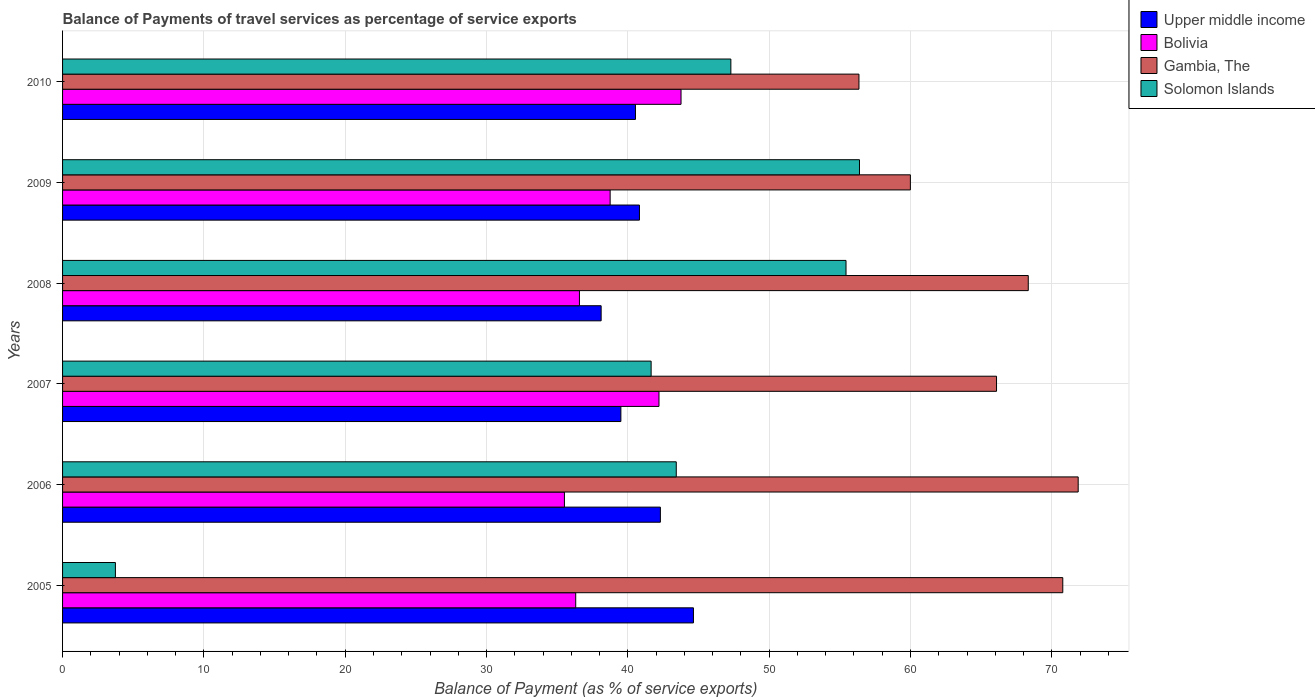How many different coloured bars are there?
Provide a succinct answer. 4. How many groups of bars are there?
Offer a terse response. 6. In how many cases, is the number of bars for a given year not equal to the number of legend labels?
Offer a very short reply. 0. What is the balance of payments of travel services in Gambia, The in 2006?
Give a very brief answer. 71.86. Across all years, what is the maximum balance of payments of travel services in Bolivia?
Make the answer very short. 43.76. Across all years, what is the minimum balance of payments of travel services in Bolivia?
Make the answer very short. 35.51. In which year was the balance of payments of travel services in Solomon Islands minimum?
Make the answer very short. 2005. What is the total balance of payments of travel services in Solomon Islands in the graph?
Make the answer very short. 247.92. What is the difference between the balance of payments of travel services in Upper middle income in 2007 and that in 2010?
Offer a terse response. -1.03. What is the difference between the balance of payments of travel services in Bolivia in 2009 and the balance of payments of travel services in Gambia, The in 2007?
Your answer should be very brief. -27.34. What is the average balance of payments of travel services in Solomon Islands per year?
Your answer should be compact. 41.32. In the year 2009, what is the difference between the balance of payments of travel services in Gambia, The and balance of payments of travel services in Upper middle income?
Your answer should be very brief. 19.17. What is the ratio of the balance of payments of travel services in Bolivia in 2005 to that in 2010?
Provide a short and direct response. 0.83. Is the balance of payments of travel services in Gambia, The in 2009 less than that in 2010?
Give a very brief answer. No. Is the difference between the balance of payments of travel services in Gambia, The in 2006 and 2010 greater than the difference between the balance of payments of travel services in Upper middle income in 2006 and 2010?
Your answer should be very brief. Yes. What is the difference between the highest and the second highest balance of payments of travel services in Gambia, The?
Ensure brevity in your answer.  1.09. What is the difference between the highest and the lowest balance of payments of travel services in Upper middle income?
Give a very brief answer. 6.53. Is the sum of the balance of payments of travel services in Solomon Islands in 2008 and 2010 greater than the maximum balance of payments of travel services in Upper middle income across all years?
Provide a succinct answer. Yes. What does the 3rd bar from the top in 2010 represents?
Offer a very short reply. Bolivia. What does the 1st bar from the bottom in 2008 represents?
Offer a terse response. Upper middle income. What is the difference between two consecutive major ticks on the X-axis?
Keep it short and to the point. 10. Does the graph contain grids?
Your answer should be compact. Yes. How many legend labels are there?
Keep it short and to the point. 4. How are the legend labels stacked?
Offer a terse response. Vertical. What is the title of the graph?
Offer a very short reply. Balance of Payments of travel services as percentage of service exports. Does "Senegal" appear as one of the legend labels in the graph?
Give a very brief answer. No. What is the label or title of the X-axis?
Your answer should be very brief. Balance of Payment (as % of service exports). What is the Balance of Payment (as % of service exports) of Upper middle income in 2005?
Ensure brevity in your answer.  44.64. What is the Balance of Payment (as % of service exports) in Bolivia in 2005?
Give a very brief answer. 36.31. What is the Balance of Payment (as % of service exports) of Gambia, The in 2005?
Offer a terse response. 70.77. What is the Balance of Payment (as % of service exports) in Solomon Islands in 2005?
Your response must be concise. 3.74. What is the Balance of Payment (as % of service exports) in Upper middle income in 2006?
Your answer should be very brief. 42.3. What is the Balance of Payment (as % of service exports) in Bolivia in 2006?
Your answer should be compact. 35.51. What is the Balance of Payment (as % of service exports) of Gambia, The in 2006?
Offer a terse response. 71.86. What is the Balance of Payment (as % of service exports) in Solomon Islands in 2006?
Keep it short and to the point. 43.42. What is the Balance of Payment (as % of service exports) of Upper middle income in 2007?
Your response must be concise. 39.51. What is the Balance of Payment (as % of service exports) in Bolivia in 2007?
Keep it short and to the point. 42.2. What is the Balance of Payment (as % of service exports) of Gambia, The in 2007?
Offer a very short reply. 66.09. What is the Balance of Payment (as % of service exports) in Solomon Islands in 2007?
Your answer should be compact. 41.65. What is the Balance of Payment (as % of service exports) of Upper middle income in 2008?
Make the answer very short. 38.11. What is the Balance of Payment (as % of service exports) of Bolivia in 2008?
Give a very brief answer. 36.57. What is the Balance of Payment (as % of service exports) in Gambia, The in 2008?
Your answer should be very brief. 68.33. What is the Balance of Payment (as % of service exports) of Solomon Islands in 2008?
Provide a short and direct response. 55.44. What is the Balance of Payment (as % of service exports) in Upper middle income in 2009?
Provide a succinct answer. 40.82. What is the Balance of Payment (as % of service exports) in Bolivia in 2009?
Keep it short and to the point. 38.75. What is the Balance of Payment (as % of service exports) in Gambia, The in 2009?
Make the answer very short. 59.99. What is the Balance of Payment (as % of service exports) of Solomon Islands in 2009?
Keep it short and to the point. 56.39. What is the Balance of Payment (as % of service exports) in Upper middle income in 2010?
Your response must be concise. 40.54. What is the Balance of Payment (as % of service exports) in Bolivia in 2010?
Your answer should be very brief. 43.76. What is the Balance of Payment (as % of service exports) of Gambia, The in 2010?
Give a very brief answer. 56.35. What is the Balance of Payment (as % of service exports) in Solomon Islands in 2010?
Ensure brevity in your answer.  47.29. Across all years, what is the maximum Balance of Payment (as % of service exports) in Upper middle income?
Provide a succinct answer. 44.64. Across all years, what is the maximum Balance of Payment (as % of service exports) in Bolivia?
Your response must be concise. 43.76. Across all years, what is the maximum Balance of Payment (as % of service exports) of Gambia, The?
Your answer should be compact. 71.86. Across all years, what is the maximum Balance of Payment (as % of service exports) of Solomon Islands?
Give a very brief answer. 56.39. Across all years, what is the minimum Balance of Payment (as % of service exports) in Upper middle income?
Your answer should be very brief. 38.11. Across all years, what is the minimum Balance of Payment (as % of service exports) in Bolivia?
Keep it short and to the point. 35.51. Across all years, what is the minimum Balance of Payment (as % of service exports) in Gambia, The?
Your answer should be very brief. 56.35. Across all years, what is the minimum Balance of Payment (as % of service exports) in Solomon Islands?
Keep it short and to the point. 3.74. What is the total Balance of Payment (as % of service exports) of Upper middle income in the graph?
Provide a short and direct response. 245.91. What is the total Balance of Payment (as % of service exports) in Bolivia in the graph?
Provide a short and direct response. 233.1. What is the total Balance of Payment (as % of service exports) in Gambia, The in the graph?
Keep it short and to the point. 393.4. What is the total Balance of Payment (as % of service exports) of Solomon Islands in the graph?
Your response must be concise. 247.92. What is the difference between the Balance of Payment (as % of service exports) in Upper middle income in 2005 and that in 2006?
Provide a succinct answer. 2.34. What is the difference between the Balance of Payment (as % of service exports) of Bolivia in 2005 and that in 2006?
Provide a short and direct response. 0.8. What is the difference between the Balance of Payment (as % of service exports) in Gambia, The in 2005 and that in 2006?
Keep it short and to the point. -1.09. What is the difference between the Balance of Payment (as % of service exports) of Solomon Islands in 2005 and that in 2006?
Offer a very short reply. -39.69. What is the difference between the Balance of Payment (as % of service exports) in Upper middle income in 2005 and that in 2007?
Keep it short and to the point. 5.13. What is the difference between the Balance of Payment (as % of service exports) in Bolivia in 2005 and that in 2007?
Your answer should be compact. -5.89. What is the difference between the Balance of Payment (as % of service exports) in Gambia, The in 2005 and that in 2007?
Provide a short and direct response. 4.69. What is the difference between the Balance of Payment (as % of service exports) in Solomon Islands in 2005 and that in 2007?
Your response must be concise. -37.91. What is the difference between the Balance of Payment (as % of service exports) in Upper middle income in 2005 and that in 2008?
Your response must be concise. 6.53. What is the difference between the Balance of Payment (as % of service exports) of Bolivia in 2005 and that in 2008?
Offer a very short reply. -0.26. What is the difference between the Balance of Payment (as % of service exports) in Gambia, The in 2005 and that in 2008?
Offer a terse response. 2.44. What is the difference between the Balance of Payment (as % of service exports) in Solomon Islands in 2005 and that in 2008?
Your response must be concise. -51.7. What is the difference between the Balance of Payment (as % of service exports) in Upper middle income in 2005 and that in 2009?
Your answer should be very brief. 3.82. What is the difference between the Balance of Payment (as % of service exports) of Bolivia in 2005 and that in 2009?
Your answer should be compact. -2.44. What is the difference between the Balance of Payment (as % of service exports) of Gambia, The in 2005 and that in 2009?
Give a very brief answer. 10.78. What is the difference between the Balance of Payment (as % of service exports) of Solomon Islands in 2005 and that in 2009?
Offer a very short reply. -52.65. What is the difference between the Balance of Payment (as % of service exports) in Upper middle income in 2005 and that in 2010?
Your answer should be very brief. 4.1. What is the difference between the Balance of Payment (as % of service exports) of Bolivia in 2005 and that in 2010?
Offer a very short reply. -7.45. What is the difference between the Balance of Payment (as % of service exports) in Gambia, The in 2005 and that in 2010?
Make the answer very short. 14.42. What is the difference between the Balance of Payment (as % of service exports) of Solomon Islands in 2005 and that in 2010?
Your answer should be very brief. -43.55. What is the difference between the Balance of Payment (as % of service exports) of Upper middle income in 2006 and that in 2007?
Provide a succinct answer. 2.79. What is the difference between the Balance of Payment (as % of service exports) of Bolivia in 2006 and that in 2007?
Offer a very short reply. -6.69. What is the difference between the Balance of Payment (as % of service exports) in Gambia, The in 2006 and that in 2007?
Give a very brief answer. 5.78. What is the difference between the Balance of Payment (as % of service exports) in Solomon Islands in 2006 and that in 2007?
Your answer should be compact. 1.78. What is the difference between the Balance of Payment (as % of service exports) of Upper middle income in 2006 and that in 2008?
Your answer should be very brief. 4.19. What is the difference between the Balance of Payment (as % of service exports) of Bolivia in 2006 and that in 2008?
Ensure brevity in your answer.  -1.06. What is the difference between the Balance of Payment (as % of service exports) of Gambia, The in 2006 and that in 2008?
Offer a terse response. 3.53. What is the difference between the Balance of Payment (as % of service exports) in Solomon Islands in 2006 and that in 2008?
Your answer should be very brief. -12.01. What is the difference between the Balance of Payment (as % of service exports) in Upper middle income in 2006 and that in 2009?
Ensure brevity in your answer.  1.48. What is the difference between the Balance of Payment (as % of service exports) in Bolivia in 2006 and that in 2009?
Keep it short and to the point. -3.24. What is the difference between the Balance of Payment (as % of service exports) of Gambia, The in 2006 and that in 2009?
Provide a short and direct response. 11.87. What is the difference between the Balance of Payment (as % of service exports) of Solomon Islands in 2006 and that in 2009?
Your answer should be compact. -12.96. What is the difference between the Balance of Payment (as % of service exports) in Upper middle income in 2006 and that in 2010?
Offer a very short reply. 1.76. What is the difference between the Balance of Payment (as % of service exports) of Bolivia in 2006 and that in 2010?
Ensure brevity in your answer.  -8.25. What is the difference between the Balance of Payment (as % of service exports) of Gambia, The in 2006 and that in 2010?
Provide a short and direct response. 15.51. What is the difference between the Balance of Payment (as % of service exports) of Solomon Islands in 2006 and that in 2010?
Give a very brief answer. -3.86. What is the difference between the Balance of Payment (as % of service exports) in Upper middle income in 2007 and that in 2008?
Provide a succinct answer. 1.4. What is the difference between the Balance of Payment (as % of service exports) of Bolivia in 2007 and that in 2008?
Make the answer very short. 5.63. What is the difference between the Balance of Payment (as % of service exports) in Gambia, The in 2007 and that in 2008?
Keep it short and to the point. -2.24. What is the difference between the Balance of Payment (as % of service exports) of Solomon Islands in 2007 and that in 2008?
Provide a short and direct response. -13.79. What is the difference between the Balance of Payment (as % of service exports) of Upper middle income in 2007 and that in 2009?
Offer a terse response. -1.31. What is the difference between the Balance of Payment (as % of service exports) in Bolivia in 2007 and that in 2009?
Give a very brief answer. 3.46. What is the difference between the Balance of Payment (as % of service exports) in Gambia, The in 2007 and that in 2009?
Keep it short and to the point. 6.1. What is the difference between the Balance of Payment (as % of service exports) in Solomon Islands in 2007 and that in 2009?
Provide a succinct answer. -14.74. What is the difference between the Balance of Payment (as % of service exports) in Upper middle income in 2007 and that in 2010?
Provide a succinct answer. -1.03. What is the difference between the Balance of Payment (as % of service exports) of Bolivia in 2007 and that in 2010?
Provide a short and direct response. -1.56. What is the difference between the Balance of Payment (as % of service exports) in Gambia, The in 2007 and that in 2010?
Offer a very short reply. 9.73. What is the difference between the Balance of Payment (as % of service exports) of Solomon Islands in 2007 and that in 2010?
Your answer should be very brief. -5.64. What is the difference between the Balance of Payment (as % of service exports) of Upper middle income in 2008 and that in 2009?
Your answer should be compact. -2.71. What is the difference between the Balance of Payment (as % of service exports) in Bolivia in 2008 and that in 2009?
Make the answer very short. -2.17. What is the difference between the Balance of Payment (as % of service exports) of Gambia, The in 2008 and that in 2009?
Your answer should be very brief. 8.34. What is the difference between the Balance of Payment (as % of service exports) of Solomon Islands in 2008 and that in 2009?
Your response must be concise. -0.95. What is the difference between the Balance of Payment (as % of service exports) of Upper middle income in 2008 and that in 2010?
Keep it short and to the point. -2.43. What is the difference between the Balance of Payment (as % of service exports) in Bolivia in 2008 and that in 2010?
Your response must be concise. -7.19. What is the difference between the Balance of Payment (as % of service exports) in Gambia, The in 2008 and that in 2010?
Provide a succinct answer. 11.98. What is the difference between the Balance of Payment (as % of service exports) of Solomon Islands in 2008 and that in 2010?
Your answer should be very brief. 8.15. What is the difference between the Balance of Payment (as % of service exports) in Upper middle income in 2009 and that in 2010?
Your answer should be very brief. 0.28. What is the difference between the Balance of Payment (as % of service exports) in Bolivia in 2009 and that in 2010?
Make the answer very short. -5.02. What is the difference between the Balance of Payment (as % of service exports) in Gambia, The in 2009 and that in 2010?
Give a very brief answer. 3.64. What is the difference between the Balance of Payment (as % of service exports) of Solomon Islands in 2009 and that in 2010?
Offer a very short reply. 9.1. What is the difference between the Balance of Payment (as % of service exports) in Upper middle income in 2005 and the Balance of Payment (as % of service exports) in Bolivia in 2006?
Keep it short and to the point. 9.13. What is the difference between the Balance of Payment (as % of service exports) in Upper middle income in 2005 and the Balance of Payment (as % of service exports) in Gambia, The in 2006?
Keep it short and to the point. -27.22. What is the difference between the Balance of Payment (as % of service exports) of Upper middle income in 2005 and the Balance of Payment (as % of service exports) of Solomon Islands in 2006?
Provide a short and direct response. 1.21. What is the difference between the Balance of Payment (as % of service exports) in Bolivia in 2005 and the Balance of Payment (as % of service exports) in Gambia, The in 2006?
Ensure brevity in your answer.  -35.55. What is the difference between the Balance of Payment (as % of service exports) in Bolivia in 2005 and the Balance of Payment (as % of service exports) in Solomon Islands in 2006?
Provide a short and direct response. -7.11. What is the difference between the Balance of Payment (as % of service exports) in Gambia, The in 2005 and the Balance of Payment (as % of service exports) in Solomon Islands in 2006?
Offer a very short reply. 27.35. What is the difference between the Balance of Payment (as % of service exports) of Upper middle income in 2005 and the Balance of Payment (as % of service exports) of Bolivia in 2007?
Offer a very short reply. 2.44. What is the difference between the Balance of Payment (as % of service exports) of Upper middle income in 2005 and the Balance of Payment (as % of service exports) of Gambia, The in 2007?
Provide a succinct answer. -21.45. What is the difference between the Balance of Payment (as % of service exports) in Upper middle income in 2005 and the Balance of Payment (as % of service exports) in Solomon Islands in 2007?
Offer a terse response. 2.99. What is the difference between the Balance of Payment (as % of service exports) in Bolivia in 2005 and the Balance of Payment (as % of service exports) in Gambia, The in 2007?
Make the answer very short. -29.78. What is the difference between the Balance of Payment (as % of service exports) of Bolivia in 2005 and the Balance of Payment (as % of service exports) of Solomon Islands in 2007?
Keep it short and to the point. -5.34. What is the difference between the Balance of Payment (as % of service exports) in Gambia, The in 2005 and the Balance of Payment (as % of service exports) in Solomon Islands in 2007?
Your answer should be compact. 29.13. What is the difference between the Balance of Payment (as % of service exports) in Upper middle income in 2005 and the Balance of Payment (as % of service exports) in Bolivia in 2008?
Give a very brief answer. 8.07. What is the difference between the Balance of Payment (as % of service exports) of Upper middle income in 2005 and the Balance of Payment (as % of service exports) of Gambia, The in 2008?
Offer a very short reply. -23.69. What is the difference between the Balance of Payment (as % of service exports) in Upper middle income in 2005 and the Balance of Payment (as % of service exports) in Solomon Islands in 2008?
Provide a short and direct response. -10.8. What is the difference between the Balance of Payment (as % of service exports) of Bolivia in 2005 and the Balance of Payment (as % of service exports) of Gambia, The in 2008?
Your answer should be very brief. -32.02. What is the difference between the Balance of Payment (as % of service exports) of Bolivia in 2005 and the Balance of Payment (as % of service exports) of Solomon Islands in 2008?
Ensure brevity in your answer.  -19.13. What is the difference between the Balance of Payment (as % of service exports) of Gambia, The in 2005 and the Balance of Payment (as % of service exports) of Solomon Islands in 2008?
Give a very brief answer. 15.34. What is the difference between the Balance of Payment (as % of service exports) in Upper middle income in 2005 and the Balance of Payment (as % of service exports) in Bolivia in 2009?
Offer a very short reply. 5.89. What is the difference between the Balance of Payment (as % of service exports) of Upper middle income in 2005 and the Balance of Payment (as % of service exports) of Gambia, The in 2009?
Offer a very short reply. -15.35. What is the difference between the Balance of Payment (as % of service exports) in Upper middle income in 2005 and the Balance of Payment (as % of service exports) in Solomon Islands in 2009?
Your answer should be very brief. -11.75. What is the difference between the Balance of Payment (as % of service exports) in Bolivia in 2005 and the Balance of Payment (as % of service exports) in Gambia, The in 2009?
Offer a terse response. -23.68. What is the difference between the Balance of Payment (as % of service exports) of Bolivia in 2005 and the Balance of Payment (as % of service exports) of Solomon Islands in 2009?
Your answer should be very brief. -20.08. What is the difference between the Balance of Payment (as % of service exports) in Gambia, The in 2005 and the Balance of Payment (as % of service exports) in Solomon Islands in 2009?
Keep it short and to the point. 14.39. What is the difference between the Balance of Payment (as % of service exports) of Upper middle income in 2005 and the Balance of Payment (as % of service exports) of Bolivia in 2010?
Offer a very short reply. 0.88. What is the difference between the Balance of Payment (as % of service exports) in Upper middle income in 2005 and the Balance of Payment (as % of service exports) in Gambia, The in 2010?
Ensure brevity in your answer.  -11.71. What is the difference between the Balance of Payment (as % of service exports) of Upper middle income in 2005 and the Balance of Payment (as % of service exports) of Solomon Islands in 2010?
Provide a succinct answer. -2.65. What is the difference between the Balance of Payment (as % of service exports) in Bolivia in 2005 and the Balance of Payment (as % of service exports) in Gambia, The in 2010?
Make the answer very short. -20.04. What is the difference between the Balance of Payment (as % of service exports) of Bolivia in 2005 and the Balance of Payment (as % of service exports) of Solomon Islands in 2010?
Ensure brevity in your answer.  -10.98. What is the difference between the Balance of Payment (as % of service exports) in Gambia, The in 2005 and the Balance of Payment (as % of service exports) in Solomon Islands in 2010?
Your answer should be compact. 23.49. What is the difference between the Balance of Payment (as % of service exports) in Upper middle income in 2006 and the Balance of Payment (as % of service exports) in Bolivia in 2007?
Your response must be concise. 0.1. What is the difference between the Balance of Payment (as % of service exports) of Upper middle income in 2006 and the Balance of Payment (as % of service exports) of Gambia, The in 2007?
Provide a short and direct response. -23.79. What is the difference between the Balance of Payment (as % of service exports) in Upper middle income in 2006 and the Balance of Payment (as % of service exports) in Solomon Islands in 2007?
Provide a short and direct response. 0.65. What is the difference between the Balance of Payment (as % of service exports) in Bolivia in 2006 and the Balance of Payment (as % of service exports) in Gambia, The in 2007?
Your answer should be very brief. -30.58. What is the difference between the Balance of Payment (as % of service exports) of Bolivia in 2006 and the Balance of Payment (as % of service exports) of Solomon Islands in 2007?
Your answer should be compact. -6.13. What is the difference between the Balance of Payment (as % of service exports) in Gambia, The in 2006 and the Balance of Payment (as % of service exports) in Solomon Islands in 2007?
Offer a terse response. 30.22. What is the difference between the Balance of Payment (as % of service exports) of Upper middle income in 2006 and the Balance of Payment (as % of service exports) of Bolivia in 2008?
Offer a very short reply. 5.73. What is the difference between the Balance of Payment (as % of service exports) of Upper middle income in 2006 and the Balance of Payment (as % of service exports) of Gambia, The in 2008?
Provide a succinct answer. -26.03. What is the difference between the Balance of Payment (as % of service exports) of Upper middle income in 2006 and the Balance of Payment (as % of service exports) of Solomon Islands in 2008?
Provide a succinct answer. -13.14. What is the difference between the Balance of Payment (as % of service exports) in Bolivia in 2006 and the Balance of Payment (as % of service exports) in Gambia, The in 2008?
Ensure brevity in your answer.  -32.82. What is the difference between the Balance of Payment (as % of service exports) in Bolivia in 2006 and the Balance of Payment (as % of service exports) in Solomon Islands in 2008?
Provide a short and direct response. -19.93. What is the difference between the Balance of Payment (as % of service exports) in Gambia, The in 2006 and the Balance of Payment (as % of service exports) in Solomon Islands in 2008?
Your response must be concise. 16.43. What is the difference between the Balance of Payment (as % of service exports) of Upper middle income in 2006 and the Balance of Payment (as % of service exports) of Bolivia in 2009?
Your answer should be compact. 3.55. What is the difference between the Balance of Payment (as % of service exports) in Upper middle income in 2006 and the Balance of Payment (as % of service exports) in Gambia, The in 2009?
Provide a succinct answer. -17.69. What is the difference between the Balance of Payment (as % of service exports) in Upper middle income in 2006 and the Balance of Payment (as % of service exports) in Solomon Islands in 2009?
Keep it short and to the point. -14.09. What is the difference between the Balance of Payment (as % of service exports) in Bolivia in 2006 and the Balance of Payment (as % of service exports) in Gambia, The in 2009?
Offer a terse response. -24.48. What is the difference between the Balance of Payment (as % of service exports) in Bolivia in 2006 and the Balance of Payment (as % of service exports) in Solomon Islands in 2009?
Ensure brevity in your answer.  -20.88. What is the difference between the Balance of Payment (as % of service exports) in Gambia, The in 2006 and the Balance of Payment (as % of service exports) in Solomon Islands in 2009?
Give a very brief answer. 15.47. What is the difference between the Balance of Payment (as % of service exports) of Upper middle income in 2006 and the Balance of Payment (as % of service exports) of Bolivia in 2010?
Offer a terse response. -1.46. What is the difference between the Balance of Payment (as % of service exports) of Upper middle income in 2006 and the Balance of Payment (as % of service exports) of Gambia, The in 2010?
Your answer should be compact. -14.05. What is the difference between the Balance of Payment (as % of service exports) of Upper middle income in 2006 and the Balance of Payment (as % of service exports) of Solomon Islands in 2010?
Your answer should be very brief. -4.99. What is the difference between the Balance of Payment (as % of service exports) in Bolivia in 2006 and the Balance of Payment (as % of service exports) in Gambia, The in 2010?
Provide a short and direct response. -20.84. What is the difference between the Balance of Payment (as % of service exports) in Bolivia in 2006 and the Balance of Payment (as % of service exports) in Solomon Islands in 2010?
Give a very brief answer. -11.78. What is the difference between the Balance of Payment (as % of service exports) of Gambia, The in 2006 and the Balance of Payment (as % of service exports) of Solomon Islands in 2010?
Keep it short and to the point. 24.58. What is the difference between the Balance of Payment (as % of service exports) in Upper middle income in 2007 and the Balance of Payment (as % of service exports) in Bolivia in 2008?
Your answer should be very brief. 2.93. What is the difference between the Balance of Payment (as % of service exports) in Upper middle income in 2007 and the Balance of Payment (as % of service exports) in Gambia, The in 2008?
Provide a short and direct response. -28.83. What is the difference between the Balance of Payment (as % of service exports) in Upper middle income in 2007 and the Balance of Payment (as % of service exports) in Solomon Islands in 2008?
Make the answer very short. -15.93. What is the difference between the Balance of Payment (as % of service exports) of Bolivia in 2007 and the Balance of Payment (as % of service exports) of Gambia, The in 2008?
Give a very brief answer. -26.13. What is the difference between the Balance of Payment (as % of service exports) of Bolivia in 2007 and the Balance of Payment (as % of service exports) of Solomon Islands in 2008?
Give a very brief answer. -13.23. What is the difference between the Balance of Payment (as % of service exports) of Gambia, The in 2007 and the Balance of Payment (as % of service exports) of Solomon Islands in 2008?
Provide a short and direct response. 10.65. What is the difference between the Balance of Payment (as % of service exports) in Upper middle income in 2007 and the Balance of Payment (as % of service exports) in Bolivia in 2009?
Offer a terse response. 0.76. What is the difference between the Balance of Payment (as % of service exports) of Upper middle income in 2007 and the Balance of Payment (as % of service exports) of Gambia, The in 2009?
Ensure brevity in your answer.  -20.48. What is the difference between the Balance of Payment (as % of service exports) of Upper middle income in 2007 and the Balance of Payment (as % of service exports) of Solomon Islands in 2009?
Offer a terse response. -16.88. What is the difference between the Balance of Payment (as % of service exports) of Bolivia in 2007 and the Balance of Payment (as % of service exports) of Gambia, The in 2009?
Offer a very short reply. -17.79. What is the difference between the Balance of Payment (as % of service exports) of Bolivia in 2007 and the Balance of Payment (as % of service exports) of Solomon Islands in 2009?
Your answer should be compact. -14.19. What is the difference between the Balance of Payment (as % of service exports) in Gambia, The in 2007 and the Balance of Payment (as % of service exports) in Solomon Islands in 2009?
Keep it short and to the point. 9.7. What is the difference between the Balance of Payment (as % of service exports) of Upper middle income in 2007 and the Balance of Payment (as % of service exports) of Bolivia in 2010?
Ensure brevity in your answer.  -4.26. What is the difference between the Balance of Payment (as % of service exports) in Upper middle income in 2007 and the Balance of Payment (as % of service exports) in Gambia, The in 2010?
Your answer should be compact. -16.85. What is the difference between the Balance of Payment (as % of service exports) of Upper middle income in 2007 and the Balance of Payment (as % of service exports) of Solomon Islands in 2010?
Offer a terse response. -7.78. What is the difference between the Balance of Payment (as % of service exports) in Bolivia in 2007 and the Balance of Payment (as % of service exports) in Gambia, The in 2010?
Your answer should be very brief. -14.15. What is the difference between the Balance of Payment (as % of service exports) of Bolivia in 2007 and the Balance of Payment (as % of service exports) of Solomon Islands in 2010?
Keep it short and to the point. -5.09. What is the difference between the Balance of Payment (as % of service exports) in Gambia, The in 2007 and the Balance of Payment (as % of service exports) in Solomon Islands in 2010?
Provide a succinct answer. 18.8. What is the difference between the Balance of Payment (as % of service exports) of Upper middle income in 2008 and the Balance of Payment (as % of service exports) of Bolivia in 2009?
Ensure brevity in your answer.  -0.64. What is the difference between the Balance of Payment (as % of service exports) of Upper middle income in 2008 and the Balance of Payment (as % of service exports) of Gambia, The in 2009?
Offer a terse response. -21.88. What is the difference between the Balance of Payment (as % of service exports) of Upper middle income in 2008 and the Balance of Payment (as % of service exports) of Solomon Islands in 2009?
Offer a very short reply. -18.28. What is the difference between the Balance of Payment (as % of service exports) in Bolivia in 2008 and the Balance of Payment (as % of service exports) in Gambia, The in 2009?
Offer a terse response. -23.42. What is the difference between the Balance of Payment (as % of service exports) of Bolivia in 2008 and the Balance of Payment (as % of service exports) of Solomon Islands in 2009?
Provide a short and direct response. -19.82. What is the difference between the Balance of Payment (as % of service exports) of Gambia, The in 2008 and the Balance of Payment (as % of service exports) of Solomon Islands in 2009?
Your answer should be very brief. 11.94. What is the difference between the Balance of Payment (as % of service exports) of Upper middle income in 2008 and the Balance of Payment (as % of service exports) of Bolivia in 2010?
Your answer should be compact. -5.65. What is the difference between the Balance of Payment (as % of service exports) of Upper middle income in 2008 and the Balance of Payment (as % of service exports) of Gambia, The in 2010?
Ensure brevity in your answer.  -18.24. What is the difference between the Balance of Payment (as % of service exports) in Upper middle income in 2008 and the Balance of Payment (as % of service exports) in Solomon Islands in 2010?
Make the answer very short. -9.18. What is the difference between the Balance of Payment (as % of service exports) of Bolivia in 2008 and the Balance of Payment (as % of service exports) of Gambia, The in 2010?
Provide a succinct answer. -19.78. What is the difference between the Balance of Payment (as % of service exports) of Bolivia in 2008 and the Balance of Payment (as % of service exports) of Solomon Islands in 2010?
Your answer should be compact. -10.71. What is the difference between the Balance of Payment (as % of service exports) of Gambia, The in 2008 and the Balance of Payment (as % of service exports) of Solomon Islands in 2010?
Your answer should be very brief. 21.04. What is the difference between the Balance of Payment (as % of service exports) of Upper middle income in 2009 and the Balance of Payment (as % of service exports) of Bolivia in 2010?
Give a very brief answer. -2.94. What is the difference between the Balance of Payment (as % of service exports) of Upper middle income in 2009 and the Balance of Payment (as % of service exports) of Gambia, The in 2010?
Your answer should be compact. -15.53. What is the difference between the Balance of Payment (as % of service exports) in Upper middle income in 2009 and the Balance of Payment (as % of service exports) in Solomon Islands in 2010?
Make the answer very short. -6.47. What is the difference between the Balance of Payment (as % of service exports) of Bolivia in 2009 and the Balance of Payment (as % of service exports) of Gambia, The in 2010?
Your answer should be compact. -17.61. What is the difference between the Balance of Payment (as % of service exports) of Bolivia in 2009 and the Balance of Payment (as % of service exports) of Solomon Islands in 2010?
Keep it short and to the point. -8.54. What is the difference between the Balance of Payment (as % of service exports) of Gambia, The in 2009 and the Balance of Payment (as % of service exports) of Solomon Islands in 2010?
Give a very brief answer. 12.7. What is the average Balance of Payment (as % of service exports) of Upper middle income per year?
Your answer should be very brief. 40.99. What is the average Balance of Payment (as % of service exports) in Bolivia per year?
Your response must be concise. 38.85. What is the average Balance of Payment (as % of service exports) of Gambia, The per year?
Make the answer very short. 65.57. What is the average Balance of Payment (as % of service exports) in Solomon Islands per year?
Offer a very short reply. 41.32. In the year 2005, what is the difference between the Balance of Payment (as % of service exports) in Upper middle income and Balance of Payment (as % of service exports) in Bolivia?
Provide a succinct answer. 8.33. In the year 2005, what is the difference between the Balance of Payment (as % of service exports) in Upper middle income and Balance of Payment (as % of service exports) in Gambia, The?
Offer a terse response. -26.13. In the year 2005, what is the difference between the Balance of Payment (as % of service exports) of Upper middle income and Balance of Payment (as % of service exports) of Solomon Islands?
Offer a terse response. 40.9. In the year 2005, what is the difference between the Balance of Payment (as % of service exports) of Bolivia and Balance of Payment (as % of service exports) of Gambia, The?
Ensure brevity in your answer.  -34.46. In the year 2005, what is the difference between the Balance of Payment (as % of service exports) of Bolivia and Balance of Payment (as % of service exports) of Solomon Islands?
Your answer should be very brief. 32.57. In the year 2005, what is the difference between the Balance of Payment (as % of service exports) in Gambia, The and Balance of Payment (as % of service exports) in Solomon Islands?
Offer a very short reply. 67.04. In the year 2006, what is the difference between the Balance of Payment (as % of service exports) in Upper middle income and Balance of Payment (as % of service exports) in Bolivia?
Your answer should be very brief. 6.79. In the year 2006, what is the difference between the Balance of Payment (as % of service exports) of Upper middle income and Balance of Payment (as % of service exports) of Gambia, The?
Give a very brief answer. -29.56. In the year 2006, what is the difference between the Balance of Payment (as % of service exports) of Upper middle income and Balance of Payment (as % of service exports) of Solomon Islands?
Make the answer very short. -1.12. In the year 2006, what is the difference between the Balance of Payment (as % of service exports) in Bolivia and Balance of Payment (as % of service exports) in Gambia, The?
Your response must be concise. -36.35. In the year 2006, what is the difference between the Balance of Payment (as % of service exports) in Bolivia and Balance of Payment (as % of service exports) in Solomon Islands?
Your answer should be very brief. -7.91. In the year 2006, what is the difference between the Balance of Payment (as % of service exports) in Gambia, The and Balance of Payment (as % of service exports) in Solomon Islands?
Offer a terse response. 28.44. In the year 2007, what is the difference between the Balance of Payment (as % of service exports) in Upper middle income and Balance of Payment (as % of service exports) in Bolivia?
Give a very brief answer. -2.7. In the year 2007, what is the difference between the Balance of Payment (as % of service exports) in Upper middle income and Balance of Payment (as % of service exports) in Gambia, The?
Ensure brevity in your answer.  -26.58. In the year 2007, what is the difference between the Balance of Payment (as % of service exports) of Upper middle income and Balance of Payment (as % of service exports) of Solomon Islands?
Ensure brevity in your answer.  -2.14. In the year 2007, what is the difference between the Balance of Payment (as % of service exports) of Bolivia and Balance of Payment (as % of service exports) of Gambia, The?
Keep it short and to the point. -23.88. In the year 2007, what is the difference between the Balance of Payment (as % of service exports) of Bolivia and Balance of Payment (as % of service exports) of Solomon Islands?
Your response must be concise. 0.56. In the year 2007, what is the difference between the Balance of Payment (as % of service exports) of Gambia, The and Balance of Payment (as % of service exports) of Solomon Islands?
Make the answer very short. 24.44. In the year 2008, what is the difference between the Balance of Payment (as % of service exports) of Upper middle income and Balance of Payment (as % of service exports) of Bolivia?
Keep it short and to the point. 1.54. In the year 2008, what is the difference between the Balance of Payment (as % of service exports) of Upper middle income and Balance of Payment (as % of service exports) of Gambia, The?
Ensure brevity in your answer.  -30.22. In the year 2008, what is the difference between the Balance of Payment (as % of service exports) of Upper middle income and Balance of Payment (as % of service exports) of Solomon Islands?
Give a very brief answer. -17.33. In the year 2008, what is the difference between the Balance of Payment (as % of service exports) of Bolivia and Balance of Payment (as % of service exports) of Gambia, The?
Give a very brief answer. -31.76. In the year 2008, what is the difference between the Balance of Payment (as % of service exports) in Bolivia and Balance of Payment (as % of service exports) in Solomon Islands?
Offer a very short reply. -18.86. In the year 2008, what is the difference between the Balance of Payment (as % of service exports) of Gambia, The and Balance of Payment (as % of service exports) of Solomon Islands?
Your answer should be very brief. 12.89. In the year 2009, what is the difference between the Balance of Payment (as % of service exports) of Upper middle income and Balance of Payment (as % of service exports) of Bolivia?
Make the answer very short. 2.07. In the year 2009, what is the difference between the Balance of Payment (as % of service exports) of Upper middle income and Balance of Payment (as % of service exports) of Gambia, The?
Ensure brevity in your answer.  -19.17. In the year 2009, what is the difference between the Balance of Payment (as % of service exports) of Upper middle income and Balance of Payment (as % of service exports) of Solomon Islands?
Make the answer very short. -15.57. In the year 2009, what is the difference between the Balance of Payment (as % of service exports) in Bolivia and Balance of Payment (as % of service exports) in Gambia, The?
Ensure brevity in your answer.  -21.24. In the year 2009, what is the difference between the Balance of Payment (as % of service exports) in Bolivia and Balance of Payment (as % of service exports) in Solomon Islands?
Your answer should be very brief. -17.64. In the year 2009, what is the difference between the Balance of Payment (as % of service exports) of Gambia, The and Balance of Payment (as % of service exports) of Solomon Islands?
Your answer should be compact. 3.6. In the year 2010, what is the difference between the Balance of Payment (as % of service exports) in Upper middle income and Balance of Payment (as % of service exports) in Bolivia?
Your answer should be very brief. -3.22. In the year 2010, what is the difference between the Balance of Payment (as % of service exports) in Upper middle income and Balance of Payment (as % of service exports) in Gambia, The?
Ensure brevity in your answer.  -15.81. In the year 2010, what is the difference between the Balance of Payment (as % of service exports) of Upper middle income and Balance of Payment (as % of service exports) of Solomon Islands?
Provide a succinct answer. -6.75. In the year 2010, what is the difference between the Balance of Payment (as % of service exports) in Bolivia and Balance of Payment (as % of service exports) in Gambia, The?
Offer a terse response. -12.59. In the year 2010, what is the difference between the Balance of Payment (as % of service exports) in Bolivia and Balance of Payment (as % of service exports) in Solomon Islands?
Offer a very short reply. -3.53. In the year 2010, what is the difference between the Balance of Payment (as % of service exports) of Gambia, The and Balance of Payment (as % of service exports) of Solomon Islands?
Offer a very short reply. 9.06. What is the ratio of the Balance of Payment (as % of service exports) in Upper middle income in 2005 to that in 2006?
Ensure brevity in your answer.  1.06. What is the ratio of the Balance of Payment (as % of service exports) in Bolivia in 2005 to that in 2006?
Provide a succinct answer. 1.02. What is the ratio of the Balance of Payment (as % of service exports) of Gambia, The in 2005 to that in 2006?
Make the answer very short. 0.98. What is the ratio of the Balance of Payment (as % of service exports) in Solomon Islands in 2005 to that in 2006?
Ensure brevity in your answer.  0.09. What is the ratio of the Balance of Payment (as % of service exports) in Upper middle income in 2005 to that in 2007?
Offer a very short reply. 1.13. What is the ratio of the Balance of Payment (as % of service exports) in Bolivia in 2005 to that in 2007?
Your answer should be compact. 0.86. What is the ratio of the Balance of Payment (as % of service exports) in Gambia, The in 2005 to that in 2007?
Provide a short and direct response. 1.07. What is the ratio of the Balance of Payment (as % of service exports) in Solomon Islands in 2005 to that in 2007?
Give a very brief answer. 0.09. What is the ratio of the Balance of Payment (as % of service exports) of Upper middle income in 2005 to that in 2008?
Provide a succinct answer. 1.17. What is the ratio of the Balance of Payment (as % of service exports) of Gambia, The in 2005 to that in 2008?
Provide a short and direct response. 1.04. What is the ratio of the Balance of Payment (as % of service exports) in Solomon Islands in 2005 to that in 2008?
Make the answer very short. 0.07. What is the ratio of the Balance of Payment (as % of service exports) of Upper middle income in 2005 to that in 2009?
Your response must be concise. 1.09. What is the ratio of the Balance of Payment (as % of service exports) in Bolivia in 2005 to that in 2009?
Make the answer very short. 0.94. What is the ratio of the Balance of Payment (as % of service exports) of Gambia, The in 2005 to that in 2009?
Offer a terse response. 1.18. What is the ratio of the Balance of Payment (as % of service exports) in Solomon Islands in 2005 to that in 2009?
Your answer should be very brief. 0.07. What is the ratio of the Balance of Payment (as % of service exports) of Upper middle income in 2005 to that in 2010?
Provide a short and direct response. 1.1. What is the ratio of the Balance of Payment (as % of service exports) in Bolivia in 2005 to that in 2010?
Ensure brevity in your answer.  0.83. What is the ratio of the Balance of Payment (as % of service exports) in Gambia, The in 2005 to that in 2010?
Your answer should be very brief. 1.26. What is the ratio of the Balance of Payment (as % of service exports) of Solomon Islands in 2005 to that in 2010?
Make the answer very short. 0.08. What is the ratio of the Balance of Payment (as % of service exports) in Upper middle income in 2006 to that in 2007?
Offer a very short reply. 1.07. What is the ratio of the Balance of Payment (as % of service exports) of Bolivia in 2006 to that in 2007?
Ensure brevity in your answer.  0.84. What is the ratio of the Balance of Payment (as % of service exports) of Gambia, The in 2006 to that in 2007?
Give a very brief answer. 1.09. What is the ratio of the Balance of Payment (as % of service exports) in Solomon Islands in 2006 to that in 2007?
Offer a terse response. 1.04. What is the ratio of the Balance of Payment (as % of service exports) in Upper middle income in 2006 to that in 2008?
Provide a succinct answer. 1.11. What is the ratio of the Balance of Payment (as % of service exports) in Bolivia in 2006 to that in 2008?
Provide a succinct answer. 0.97. What is the ratio of the Balance of Payment (as % of service exports) in Gambia, The in 2006 to that in 2008?
Give a very brief answer. 1.05. What is the ratio of the Balance of Payment (as % of service exports) in Solomon Islands in 2006 to that in 2008?
Your answer should be compact. 0.78. What is the ratio of the Balance of Payment (as % of service exports) of Upper middle income in 2006 to that in 2009?
Ensure brevity in your answer.  1.04. What is the ratio of the Balance of Payment (as % of service exports) of Bolivia in 2006 to that in 2009?
Your answer should be compact. 0.92. What is the ratio of the Balance of Payment (as % of service exports) in Gambia, The in 2006 to that in 2009?
Give a very brief answer. 1.2. What is the ratio of the Balance of Payment (as % of service exports) of Solomon Islands in 2006 to that in 2009?
Ensure brevity in your answer.  0.77. What is the ratio of the Balance of Payment (as % of service exports) of Upper middle income in 2006 to that in 2010?
Ensure brevity in your answer.  1.04. What is the ratio of the Balance of Payment (as % of service exports) in Bolivia in 2006 to that in 2010?
Give a very brief answer. 0.81. What is the ratio of the Balance of Payment (as % of service exports) in Gambia, The in 2006 to that in 2010?
Provide a short and direct response. 1.28. What is the ratio of the Balance of Payment (as % of service exports) in Solomon Islands in 2006 to that in 2010?
Your answer should be compact. 0.92. What is the ratio of the Balance of Payment (as % of service exports) of Upper middle income in 2007 to that in 2008?
Your answer should be very brief. 1.04. What is the ratio of the Balance of Payment (as % of service exports) of Bolivia in 2007 to that in 2008?
Offer a very short reply. 1.15. What is the ratio of the Balance of Payment (as % of service exports) of Gambia, The in 2007 to that in 2008?
Your answer should be compact. 0.97. What is the ratio of the Balance of Payment (as % of service exports) in Solomon Islands in 2007 to that in 2008?
Offer a very short reply. 0.75. What is the ratio of the Balance of Payment (as % of service exports) of Upper middle income in 2007 to that in 2009?
Your answer should be very brief. 0.97. What is the ratio of the Balance of Payment (as % of service exports) of Bolivia in 2007 to that in 2009?
Ensure brevity in your answer.  1.09. What is the ratio of the Balance of Payment (as % of service exports) in Gambia, The in 2007 to that in 2009?
Ensure brevity in your answer.  1.1. What is the ratio of the Balance of Payment (as % of service exports) of Solomon Islands in 2007 to that in 2009?
Your response must be concise. 0.74. What is the ratio of the Balance of Payment (as % of service exports) of Upper middle income in 2007 to that in 2010?
Your response must be concise. 0.97. What is the ratio of the Balance of Payment (as % of service exports) in Bolivia in 2007 to that in 2010?
Offer a very short reply. 0.96. What is the ratio of the Balance of Payment (as % of service exports) of Gambia, The in 2007 to that in 2010?
Give a very brief answer. 1.17. What is the ratio of the Balance of Payment (as % of service exports) in Solomon Islands in 2007 to that in 2010?
Provide a succinct answer. 0.88. What is the ratio of the Balance of Payment (as % of service exports) of Upper middle income in 2008 to that in 2009?
Your response must be concise. 0.93. What is the ratio of the Balance of Payment (as % of service exports) of Bolivia in 2008 to that in 2009?
Offer a terse response. 0.94. What is the ratio of the Balance of Payment (as % of service exports) of Gambia, The in 2008 to that in 2009?
Provide a short and direct response. 1.14. What is the ratio of the Balance of Payment (as % of service exports) in Solomon Islands in 2008 to that in 2009?
Your answer should be compact. 0.98. What is the ratio of the Balance of Payment (as % of service exports) of Upper middle income in 2008 to that in 2010?
Provide a succinct answer. 0.94. What is the ratio of the Balance of Payment (as % of service exports) in Bolivia in 2008 to that in 2010?
Ensure brevity in your answer.  0.84. What is the ratio of the Balance of Payment (as % of service exports) of Gambia, The in 2008 to that in 2010?
Provide a short and direct response. 1.21. What is the ratio of the Balance of Payment (as % of service exports) of Solomon Islands in 2008 to that in 2010?
Your answer should be very brief. 1.17. What is the ratio of the Balance of Payment (as % of service exports) in Bolivia in 2009 to that in 2010?
Ensure brevity in your answer.  0.89. What is the ratio of the Balance of Payment (as % of service exports) of Gambia, The in 2009 to that in 2010?
Offer a very short reply. 1.06. What is the ratio of the Balance of Payment (as % of service exports) of Solomon Islands in 2009 to that in 2010?
Provide a short and direct response. 1.19. What is the difference between the highest and the second highest Balance of Payment (as % of service exports) of Upper middle income?
Make the answer very short. 2.34. What is the difference between the highest and the second highest Balance of Payment (as % of service exports) of Bolivia?
Your response must be concise. 1.56. What is the difference between the highest and the second highest Balance of Payment (as % of service exports) in Gambia, The?
Provide a succinct answer. 1.09. What is the difference between the highest and the second highest Balance of Payment (as % of service exports) in Solomon Islands?
Ensure brevity in your answer.  0.95. What is the difference between the highest and the lowest Balance of Payment (as % of service exports) in Upper middle income?
Your answer should be very brief. 6.53. What is the difference between the highest and the lowest Balance of Payment (as % of service exports) in Bolivia?
Offer a terse response. 8.25. What is the difference between the highest and the lowest Balance of Payment (as % of service exports) of Gambia, The?
Give a very brief answer. 15.51. What is the difference between the highest and the lowest Balance of Payment (as % of service exports) in Solomon Islands?
Ensure brevity in your answer.  52.65. 